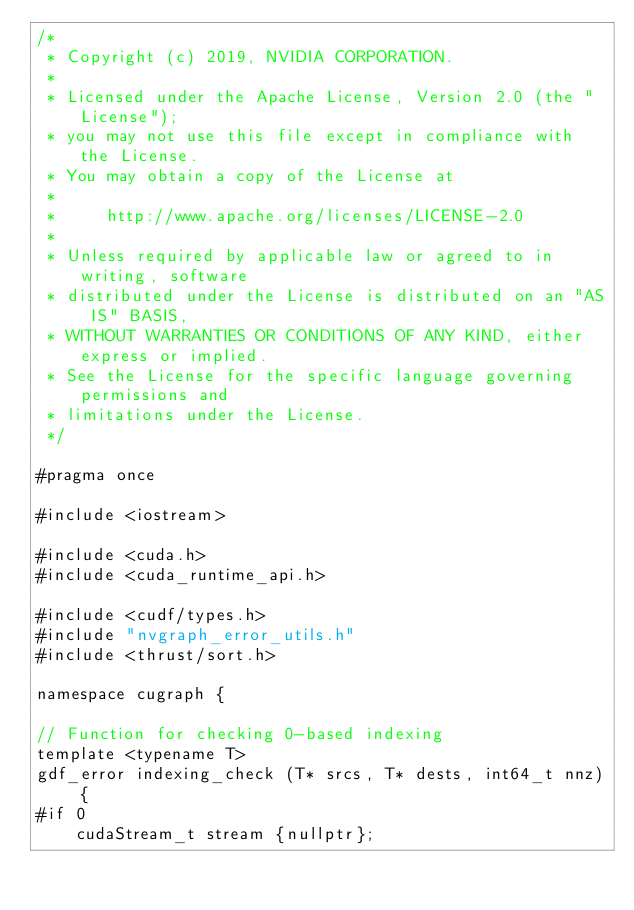Convert code to text. <code><loc_0><loc_0><loc_500><loc_500><_Cuda_>/*
 * Copyright (c) 2019, NVIDIA CORPORATION.
 *
 * Licensed under the Apache License, Version 2.0 (the "License");
 * you may not use this file except in compliance with the License.
 * You may obtain a copy of the License at
 *
 *     http://www.apache.org/licenses/LICENSE-2.0
 *
 * Unless required by applicable law or agreed to in writing, software
 * distributed under the License is distributed on an "AS IS" BASIS,
 * WITHOUT WARRANTIES OR CONDITIONS OF ANY KIND, either express or implied.
 * See the License for the specific language governing permissions and
 * limitations under the License.
 */

#pragma once

#include <iostream>

#include <cuda.h>
#include <cuda_runtime_api.h>

#include <cudf/types.h>
#include "nvgraph_error_utils.h"
#include <thrust/sort.h>

namespace cugraph {

// Function for checking 0-based indexing
template <typename T>
gdf_error indexing_check (T* srcs, T* dests, int64_t nnz) {
#if 0
    cudaStream_t stream {nullptr};
</code> 